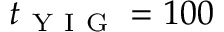<formula> <loc_0><loc_0><loc_500><loc_500>t _ { Y I G } = 1 0 0</formula> 